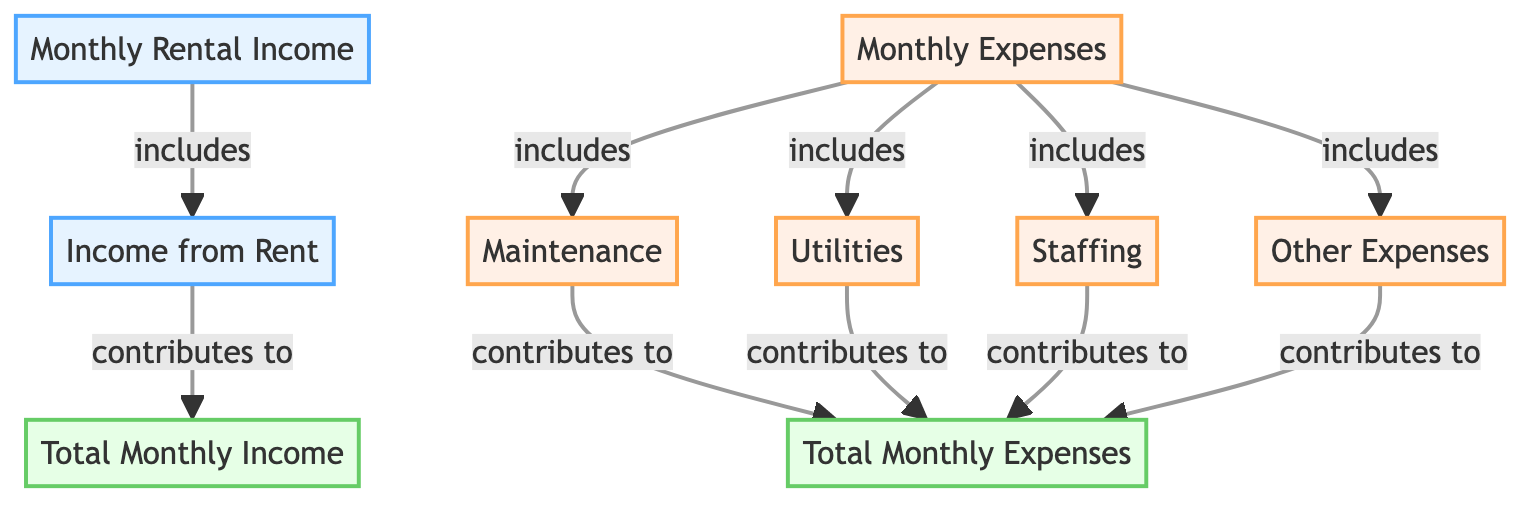What is the monthly rental income categorized as? The diagram identifies "Monthly Rental Income" with a breakdown that includes "Income from Rent." Therefore, the monthly rental income is categorized as income from rent.
Answer: Income from Rent What types of expenses are included in the monthly expenses? The diagram shows that "Monthly Expenses" include "Maintenance," "Utilities," "Staffing," and "Other Expenses." Therefore, the expenses include these four specific categories.
Answer: Maintenance, Utilities, Staffing, Other Expenses How many types of costs contribute to the total monthly expenses? Counting the nodes under "Monthly Expenses," we see that there are four types of costs: maintenance, utilities, staffing, and other expenses. Thus, there are four specific types of costs that contribute to the total.
Answer: Four What does the "Total Monthly Income" depend on? According to the diagram, "Total Monthly Income" depends on "Income from Rent," as it is the only component leading to that node. So, it relies solely on this specific income type.
Answer: Income from Rent Which cost contributes to both the monthly expenses and the total monthly expenses? The diagram shows that "Maintenance," "Utilities," "Staffing," and "Other Expenses" contribute to both "Monthly Expenses" and "Total Monthly Expenses." Therefore, all four costs are contributors to both categories.
Answer: Maintenance, Utilities, Staffing, Other Expenses What relationship exists between "Monthly Rental Income" and "Total Monthly Income"? The diagram clearly states that "Monthly Rental Income" includes "Income from Rent," which itself contributes to the "Total Monthly Income." Thus, there is a direct inclusion and contribution relationship.
Answer: Inclusion and contribution What is the main focus of the diagram? The main focus of the diagram is to provide a breakdown of the "Monthly Rental Income and Expense," categorizing the income sources and expense types visually, illustrating how they interconnect.
Answer: Monthly Rental Income and Expense Breakdown 